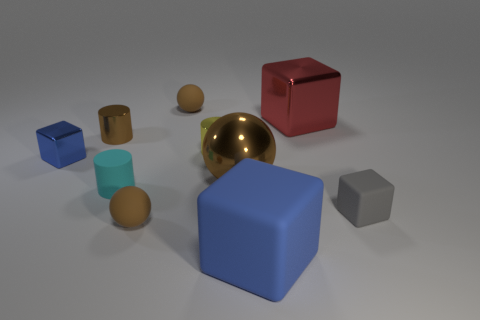Subtract all brown balls. How many were subtracted if there are1brown balls left? 2 Subtract all cylinders. How many objects are left? 7 Add 7 brown rubber spheres. How many brown rubber spheres exist? 9 Subtract 0 blue balls. How many objects are left? 10 Subtract all brown balls. Subtract all tiny brown objects. How many objects are left? 4 Add 3 gray rubber cubes. How many gray rubber cubes are left? 4 